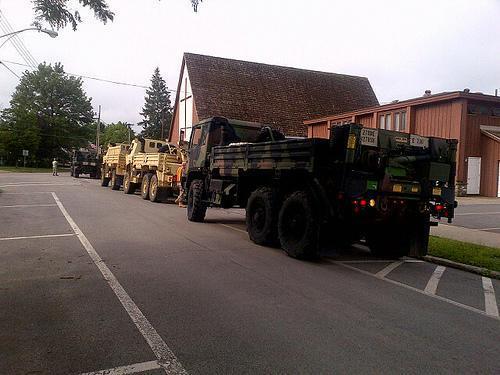How many trucks are there?
Give a very brief answer. 4. 